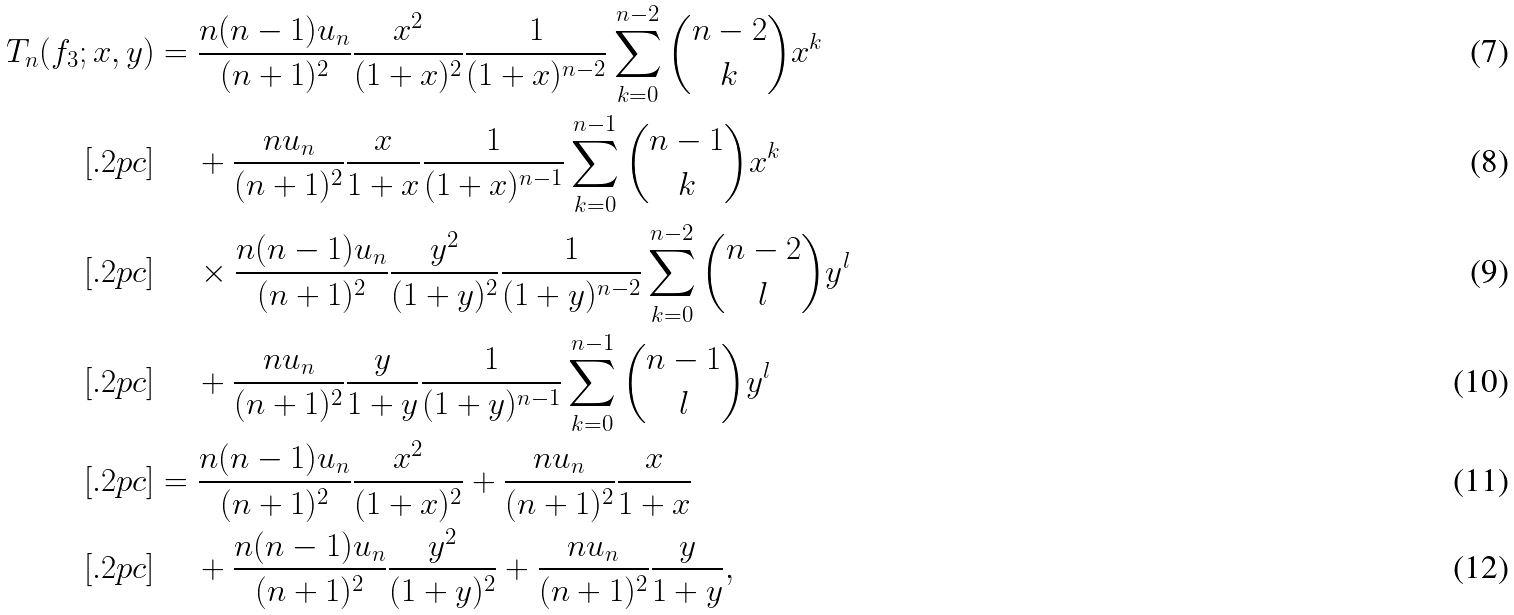Convert formula to latex. <formula><loc_0><loc_0><loc_500><loc_500>T _ { n } ( f _ { 3 } ; x , y ) & = \frac { n ( n - 1 ) u _ { n } } { ( n + 1 ) ^ { 2 } } \frac { x ^ { 2 } } { ( 1 + x ) ^ { 2 } } \frac { 1 } { ( 1 + x ) ^ { n - 2 } } \sum _ { k = 0 } ^ { n - 2 } \binom { n - 2 } { k } x ^ { k } \\ [ . 2 p c ] & \quad \, + \frac { n u _ { n } } { ( n + 1 ) ^ { 2 } } \frac { x } { 1 + x } \frac { 1 } { ( 1 + x ) ^ { n - 1 } } \sum _ { k = 0 } ^ { n - 1 } \binom { n - 1 } { k } x ^ { k } \\ [ . 2 p c ] & \quad \, \times \frac { n ( n - 1 ) u _ { n } } { ( n + 1 ) ^ { 2 } } \frac { y ^ { 2 } } { ( 1 + y ) ^ { 2 } } \frac { 1 } { ( 1 + y ) ^ { n - 2 } } \sum _ { k = 0 } ^ { n - 2 } \binom { n - 2 } { l } y ^ { l } \\ [ . 2 p c ] & \quad \, + \frac { n u _ { n } } { ( n + 1 ) ^ { 2 } } \frac { y } { 1 + y } \frac { 1 } { ( 1 + y ) ^ { n - 1 } } \sum _ { k = 0 } ^ { n - 1 } \binom { n - 1 } { l } y ^ { l } \\ [ . 2 p c ] & = \frac { n ( n - 1 ) u _ { n } } { ( n + 1 ) ^ { 2 } } \frac { x ^ { 2 } } { ( 1 + x ) ^ { 2 } } + \frac { n u _ { n } } { ( n + 1 ) ^ { 2 } } \frac { x } { 1 + x } \\ [ . 2 p c ] & \quad \, + \frac { n ( n - 1 ) u _ { n } } { ( n + 1 ) ^ { 2 } } \frac { y ^ { 2 } } { ( 1 + y ) ^ { 2 } } + \frac { n u _ { n } } { ( n + 1 ) ^ { 2 } } \frac { y } { 1 + y } ,</formula> 